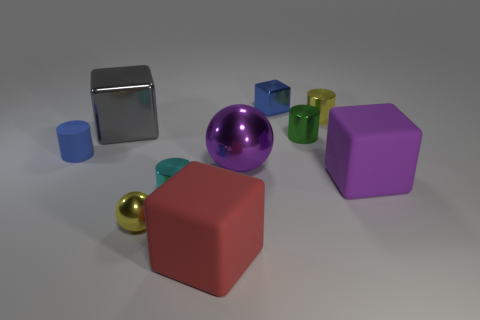Can you tell me what materials the objects in the image appear to be made of? Certainly! In the image, the objects appear to be made of different types of materials. The sphere in the center has a shiny, reflective surface, suggesting it's made of metal. The largest cube has a matte finish, indicative of a plastic material. The other smaller objects, including cubes and cylinders, also seem to have either a matte or slightly reflective surface, possibly plastic or painted wood. 